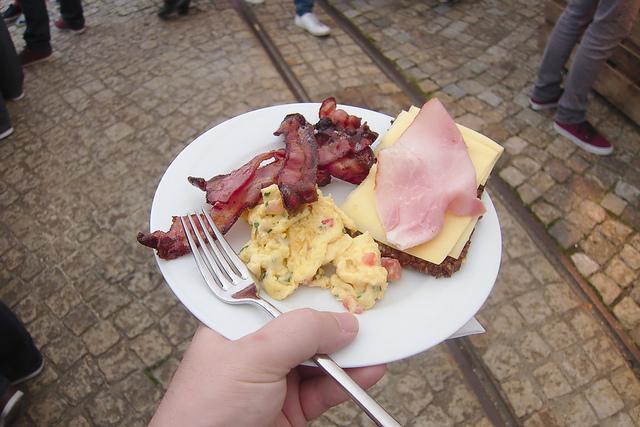How many people are in the photo?
Give a very brief answer. 4. How many of the bears legs are bent?
Give a very brief answer. 0. 